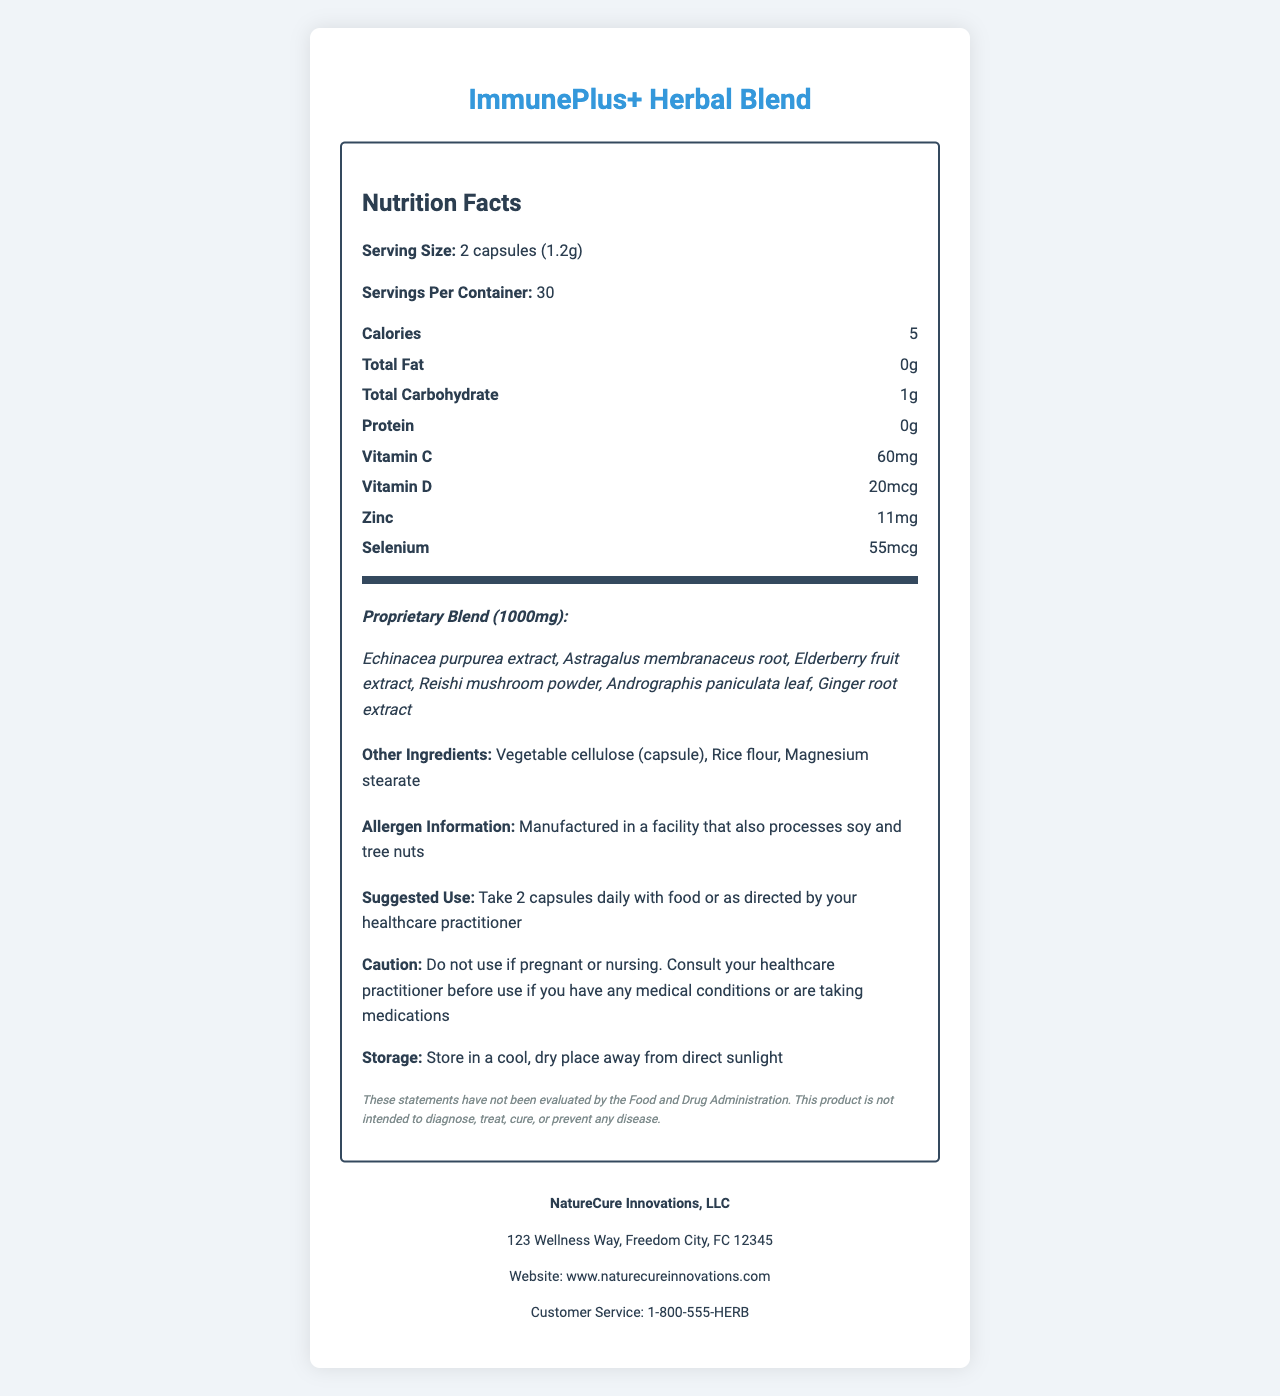what is the serving size of ImmunePlus+ Herbal Blend? The serving size is clearly mentioned as "2 capsules (1.2g)" in the Nutrition Facts section of the document.
Answer: 2 capsules (1.2g) how many calories are in one serving? The document lists "Calories: 5" under the nutrition facts.
Answer: 5 name the vitamins present in ImmunePlus+ Herbal Blend The vitamins listed are "Vitamin C" and "Vitamin D" in the nutrition facts section.
Answer: Vitamin C, Vitamin D how much zinc is contained in one serving? The amount of zinc per serving is specified as 11mg in the nutrition facts.
Answer: 11mg which ingredient in the proprietary blend is listed first? The first ingredient listed in the proprietary blend section is "Echinacea purpurea extract".
Answer: Echinacea purpurea extract where is ImmunePlus+ Herbal Blend manufactured? A. Canada B. United States C. United Kingdom D. Germany The document states that the manufacturer is "NatureCure Innovations, LLC" with an address in Freedom City, FC (presumably the United States).
Answer: B. United States how many servings per container are available? The document states "Servings Per Container: 30".
Answer: 30 what is the suggested use of the product? The suggested use information is mentioned under the usage info section.
Answer: Take 2 capsules daily with food or as directed by your healthcare practitioner which of these ingredients is NOT part of the proprietary blend? A. Ginger root extract B. Elderberry fruit extract C. Rice flour D. Reishi mushroom powder Rice flour is listed in the other ingredients section, not in the proprietary blend.
Answer: C. Rice flour is ImmunePlus+ Herbal Blend safe to use during pregnancy? The caution section states "Do not use if pregnant or nursing."
Answer: No what is the storage instruction for the product? The storage instruction is clearly mentioned in the document.
Answer: Store in a cool, dry place away from direct sunlight summarize the main idea of the document The document provides comprehensive information about the ImmunePlus+ Herbal Blend, covering various aspects like nutritional content, suggested usage, additional ingredients, allergen information, caution for use, and storage instructions, along with manufacturer contact details.
Answer: The document is a detailed nutrition facts label for ImmunePlus+ Herbal Blend, a proprietary herbal supplement blend designed to boost immune function. It includes serving size, nutrition facts, proprietary blend ingredients, usage instructions, allergen information, and manufacturer details. how much protein is in each serving of ImmunePlus+ Herbal Blend? The nutrition facts section lists "Protein: 0g".
Answer: 0g is ImmunePlus+ Herbal Blend gluten-free? The document does not specify whether the product is gluten-free. It only mentions allergen information related to soy and tree nuts.
Answer: Not enough information name the manufacturer and customer service number of the product The manufacturer is "NatureCure Innovations, LLC" and the customer service number is "1-800-555-HERB".
Answer: NatureCure Innovations, LLC, 1-800-555-HERB does ImmunePlus+ Herbal Blend contain any fat? The total fat content per serving is listed as "0g".
Answer: No 